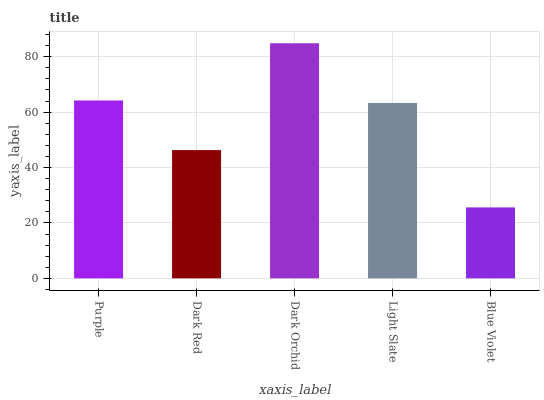Is Blue Violet the minimum?
Answer yes or no. Yes. Is Dark Orchid the maximum?
Answer yes or no. Yes. Is Dark Red the minimum?
Answer yes or no. No. Is Dark Red the maximum?
Answer yes or no. No. Is Purple greater than Dark Red?
Answer yes or no. Yes. Is Dark Red less than Purple?
Answer yes or no. Yes. Is Dark Red greater than Purple?
Answer yes or no. No. Is Purple less than Dark Red?
Answer yes or no. No. Is Light Slate the high median?
Answer yes or no. Yes. Is Light Slate the low median?
Answer yes or no. Yes. Is Dark Red the high median?
Answer yes or no. No. Is Purple the low median?
Answer yes or no. No. 